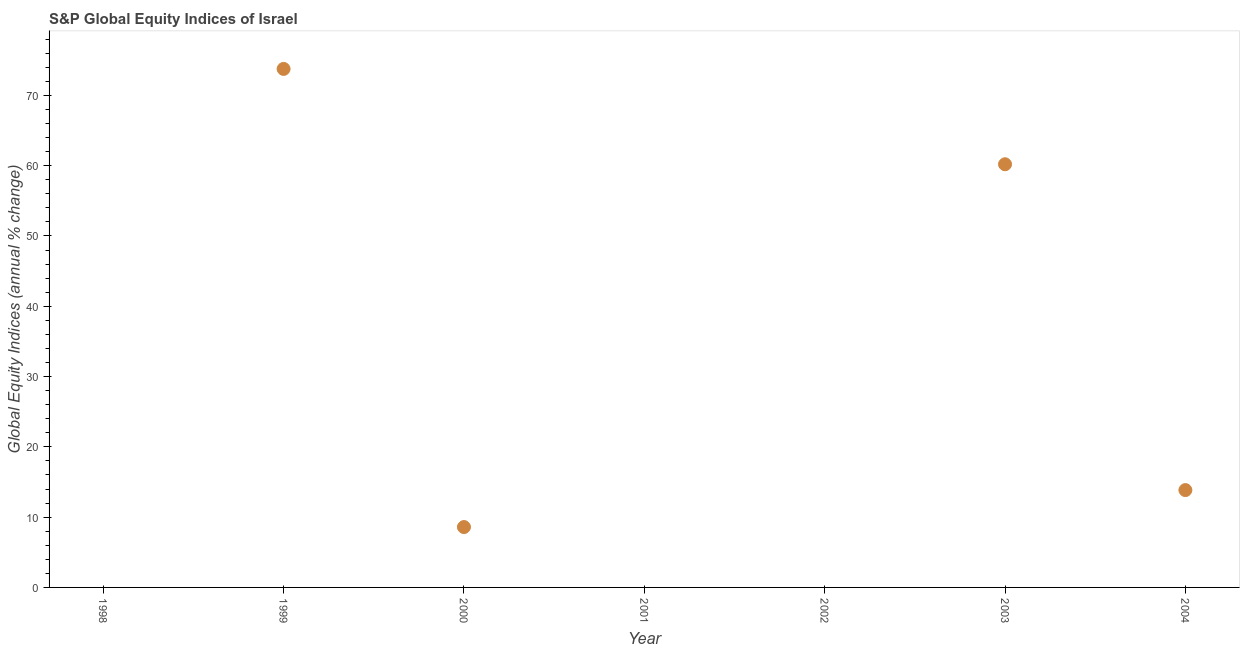What is the s&p global equity indices in 2003?
Keep it short and to the point. 60.2. Across all years, what is the maximum s&p global equity indices?
Provide a succinct answer. 73.76. In which year was the s&p global equity indices maximum?
Your answer should be very brief. 1999. What is the sum of the s&p global equity indices?
Keep it short and to the point. 156.39. What is the difference between the s&p global equity indices in 1999 and 2003?
Keep it short and to the point. 13.56. What is the average s&p global equity indices per year?
Your answer should be compact. 22.34. What is the median s&p global equity indices?
Provide a succinct answer. 8.59. In how many years, is the s&p global equity indices greater than 22 %?
Your answer should be very brief. 2. What is the ratio of the s&p global equity indices in 1999 to that in 2004?
Make the answer very short. 5.33. What is the difference between the highest and the second highest s&p global equity indices?
Give a very brief answer. 13.56. What is the difference between the highest and the lowest s&p global equity indices?
Your answer should be compact. 73.76. In how many years, is the s&p global equity indices greater than the average s&p global equity indices taken over all years?
Your answer should be very brief. 2. Does the s&p global equity indices monotonically increase over the years?
Ensure brevity in your answer.  No. How many dotlines are there?
Make the answer very short. 1. How many years are there in the graph?
Make the answer very short. 7. Does the graph contain grids?
Your answer should be compact. No. What is the title of the graph?
Make the answer very short. S&P Global Equity Indices of Israel. What is the label or title of the X-axis?
Make the answer very short. Year. What is the label or title of the Y-axis?
Keep it short and to the point. Global Equity Indices (annual % change). What is the Global Equity Indices (annual % change) in 1998?
Your answer should be compact. 0. What is the Global Equity Indices (annual % change) in 1999?
Provide a short and direct response. 73.76. What is the Global Equity Indices (annual % change) in 2000?
Your answer should be very brief. 8.59. What is the Global Equity Indices (annual % change) in 2003?
Your answer should be very brief. 60.2. What is the Global Equity Indices (annual % change) in 2004?
Provide a succinct answer. 13.85. What is the difference between the Global Equity Indices (annual % change) in 1999 and 2000?
Ensure brevity in your answer.  65.17. What is the difference between the Global Equity Indices (annual % change) in 1999 and 2003?
Provide a succinct answer. 13.56. What is the difference between the Global Equity Indices (annual % change) in 1999 and 2004?
Offer a very short reply. 59.91. What is the difference between the Global Equity Indices (annual % change) in 2000 and 2003?
Provide a succinct answer. -51.61. What is the difference between the Global Equity Indices (annual % change) in 2000 and 2004?
Ensure brevity in your answer.  -5.26. What is the difference between the Global Equity Indices (annual % change) in 2003 and 2004?
Your answer should be compact. 46.35. What is the ratio of the Global Equity Indices (annual % change) in 1999 to that in 2000?
Offer a very short reply. 8.59. What is the ratio of the Global Equity Indices (annual % change) in 1999 to that in 2003?
Provide a succinct answer. 1.23. What is the ratio of the Global Equity Indices (annual % change) in 1999 to that in 2004?
Offer a very short reply. 5.33. What is the ratio of the Global Equity Indices (annual % change) in 2000 to that in 2003?
Give a very brief answer. 0.14. What is the ratio of the Global Equity Indices (annual % change) in 2000 to that in 2004?
Offer a terse response. 0.62. What is the ratio of the Global Equity Indices (annual % change) in 2003 to that in 2004?
Provide a succinct answer. 4.35. 